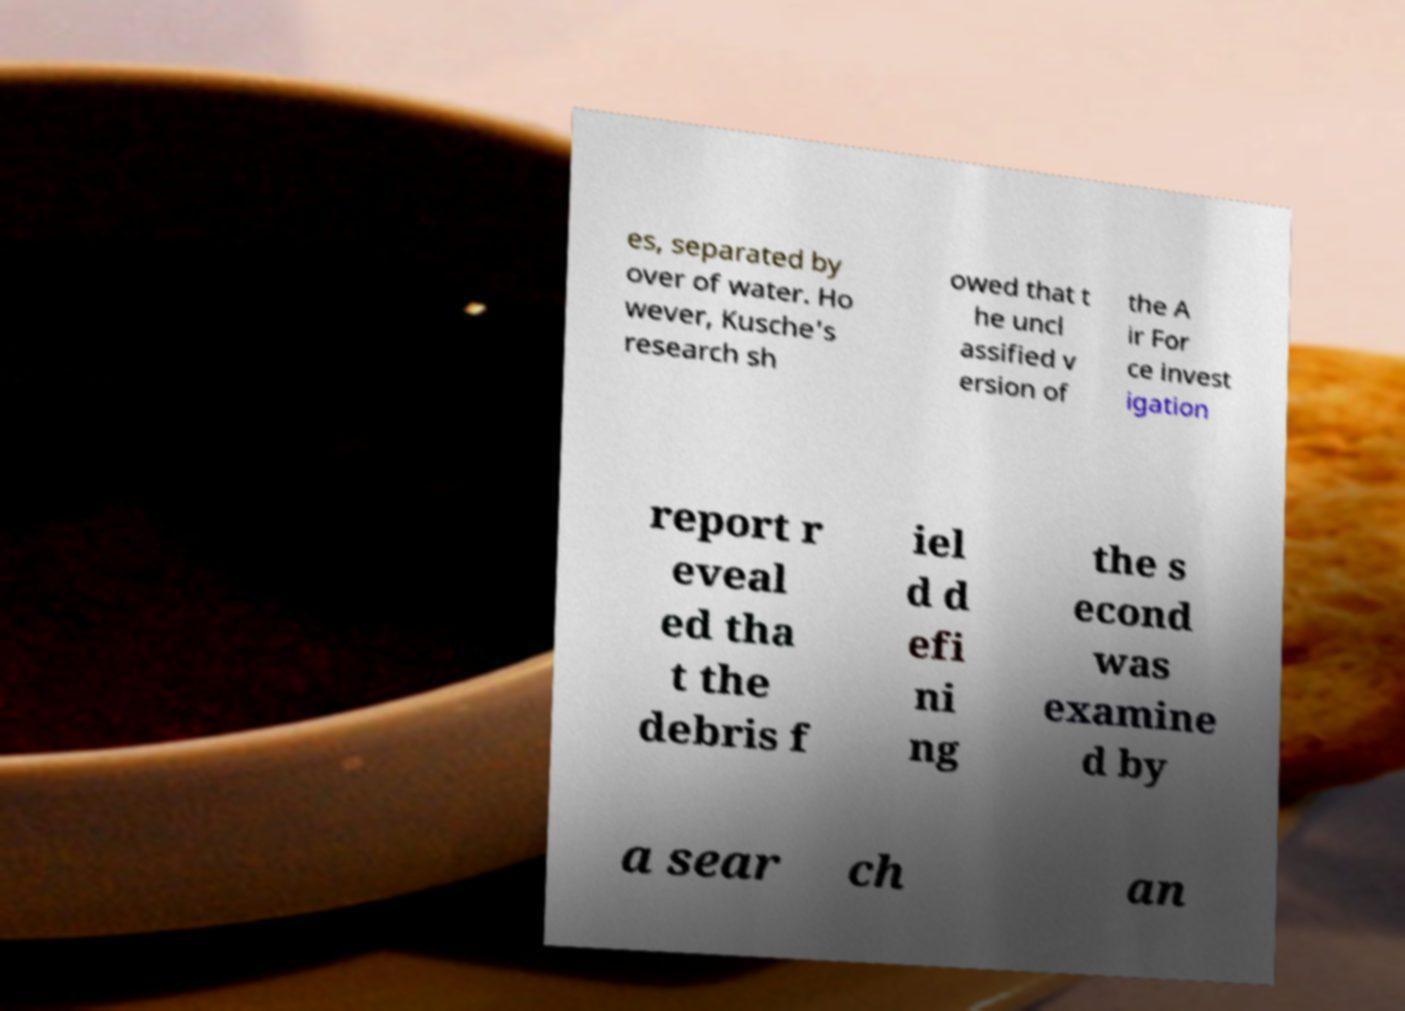For documentation purposes, I need the text within this image transcribed. Could you provide that? es, separated by over of water. Ho wever, Kusche's research sh owed that t he uncl assified v ersion of the A ir For ce invest igation report r eveal ed tha t the debris f iel d d efi ni ng the s econd was examine d by a sear ch an 